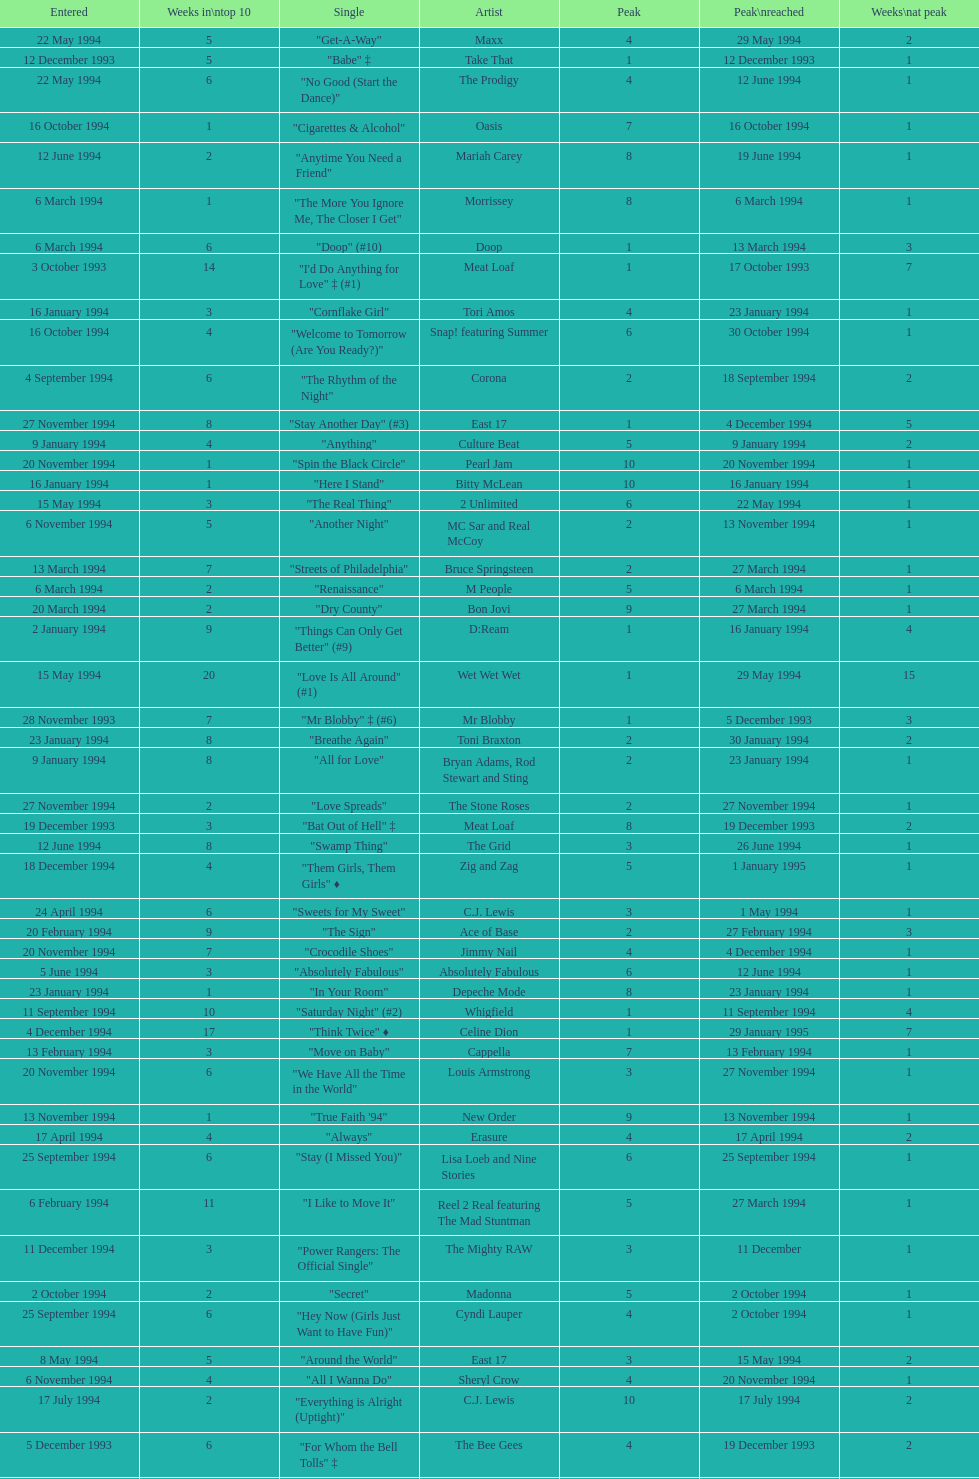Which single was the last one to be on the charts in 1993? "Come Baby Come". 